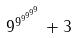<formula> <loc_0><loc_0><loc_500><loc_500>9 ^ { 9 ^ { 9 ^ { 9 ^ { 9 ^ { 9 } } } } } + 3</formula> 